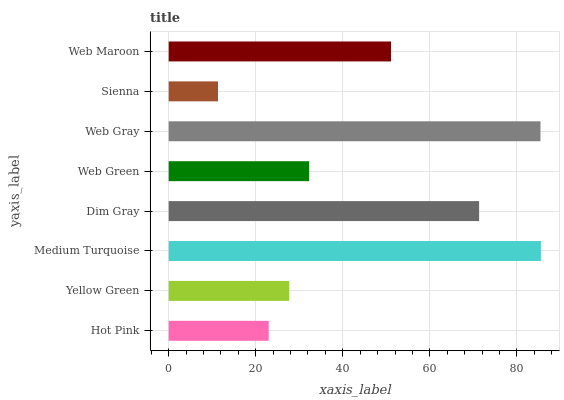Is Sienna the minimum?
Answer yes or no. Yes. Is Medium Turquoise the maximum?
Answer yes or no. Yes. Is Yellow Green the minimum?
Answer yes or no. No. Is Yellow Green the maximum?
Answer yes or no. No. Is Yellow Green greater than Hot Pink?
Answer yes or no. Yes. Is Hot Pink less than Yellow Green?
Answer yes or no. Yes. Is Hot Pink greater than Yellow Green?
Answer yes or no. No. Is Yellow Green less than Hot Pink?
Answer yes or no. No. Is Web Maroon the high median?
Answer yes or no. Yes. Is Web Green the low median?
Answer yes or no. Yes. Is Medium Turquoise the high median?
Answer yes or no. No. Is Dim Gray the low median?
Answer yes or no. No. 